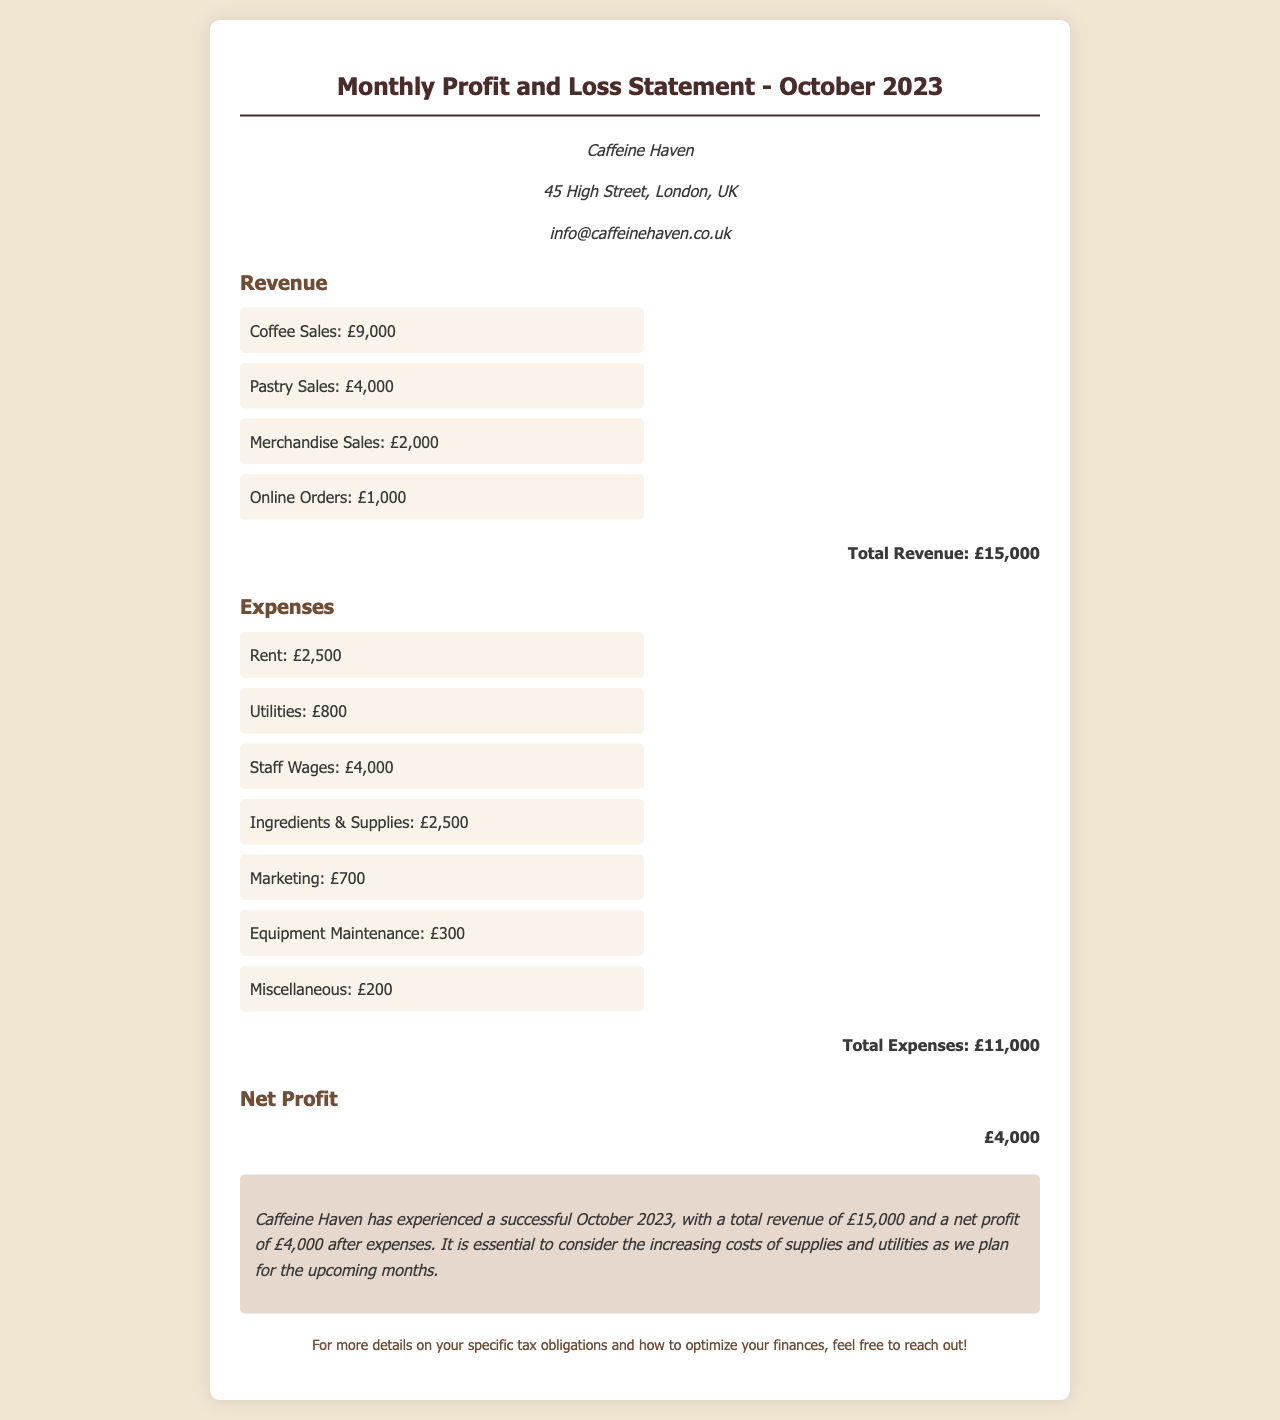What is the total revenue? The total revenue is the sum of coffee sales, pastry sales, merchandise sales, and online orders, which amounts to £9,000 + £4,000 + £2,000 + £1,000 = £15,000.
Answer: £15,000 What are the total expenses? The total expenses are the sum of all listed expenses, which adds up to £2,500 + £800 + £4,000 + £2,500 + £700 + £300 + £200 = £11,000.
Answer: £11,000 What is the net profit? The net profit is calculated as total revenue minus total expenses, which is £15,000 - £11,000 = £4,000.
Answer: £4,000 What is the largest expense category? The largest expense category listed is staff wages, which amounts to £4,000.
Answer: Staff Wages What percentage of total revenue is net profit? The net profit percentage can be calculated as (net profit / total revenue) * 100%, which is (£4,000 / £15,000) * 100% ≈ 26.67%.
Answer: 26.67% What does the summary state about October 2023 performance? The summary states that Caffeine Haven experienced a successful October 2023 with a total revenue of £15,000 and a net profit of £4,000.
Answer: Successful October What concerns are mentioned regarding future planning? The concerns mentioned are about the increasing costs of supplies and utilities.
Answer: Increasing costs What is the business name? The business name is explicitly listed at the top of the document under business info.
Answer: Caffeine Haven Which marketing expense amount is provided? The specific marketing expense amount mentioned in the document is £700.
Answer: £700 